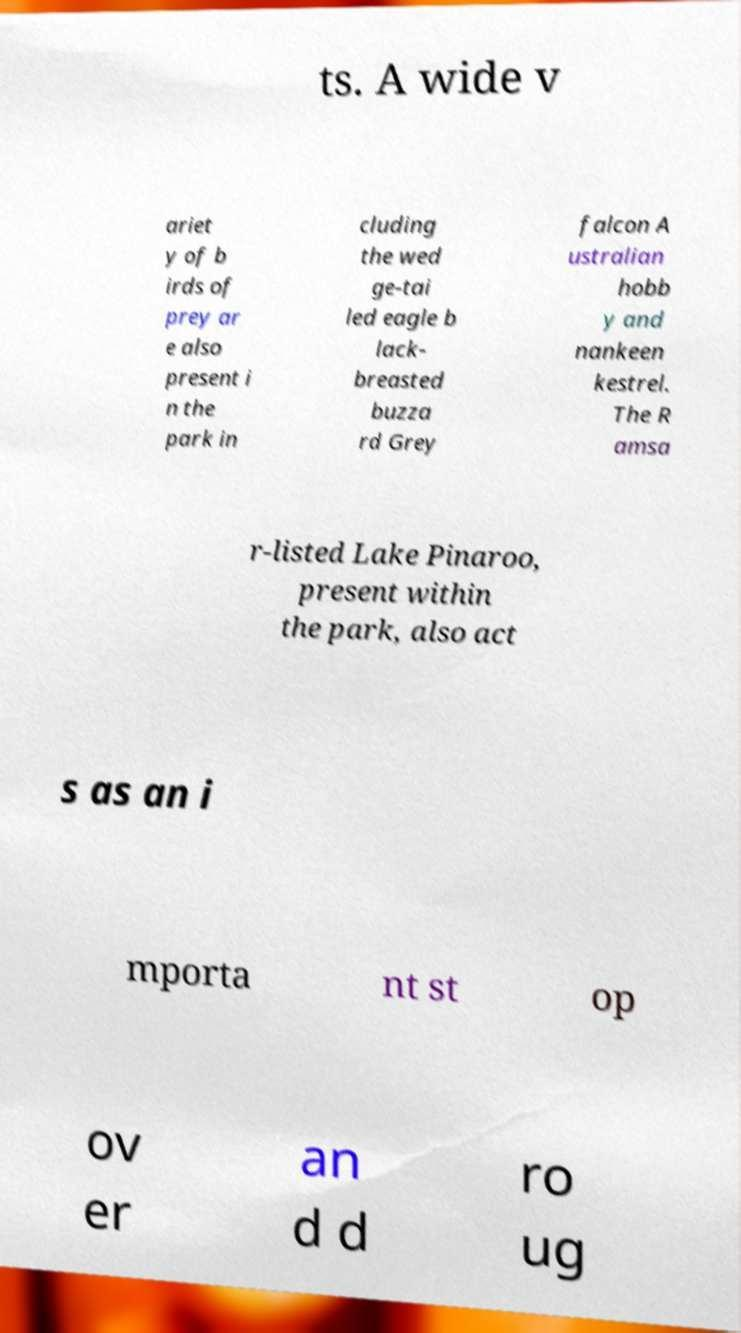Please read and relay the text visible in this image. What does it say? ts. A wide v ariet y of b irds of prey ar e also present i n the park in cluding the wed ge-tai led eagle b lack- breasted buzza rd Grey falcon A ustralian hobb y and nankeen kestrel. The R amsa r-listed Lake Pinaroo, present within the park, also act s as an i mporta nt st op ov er an d d ro ug 